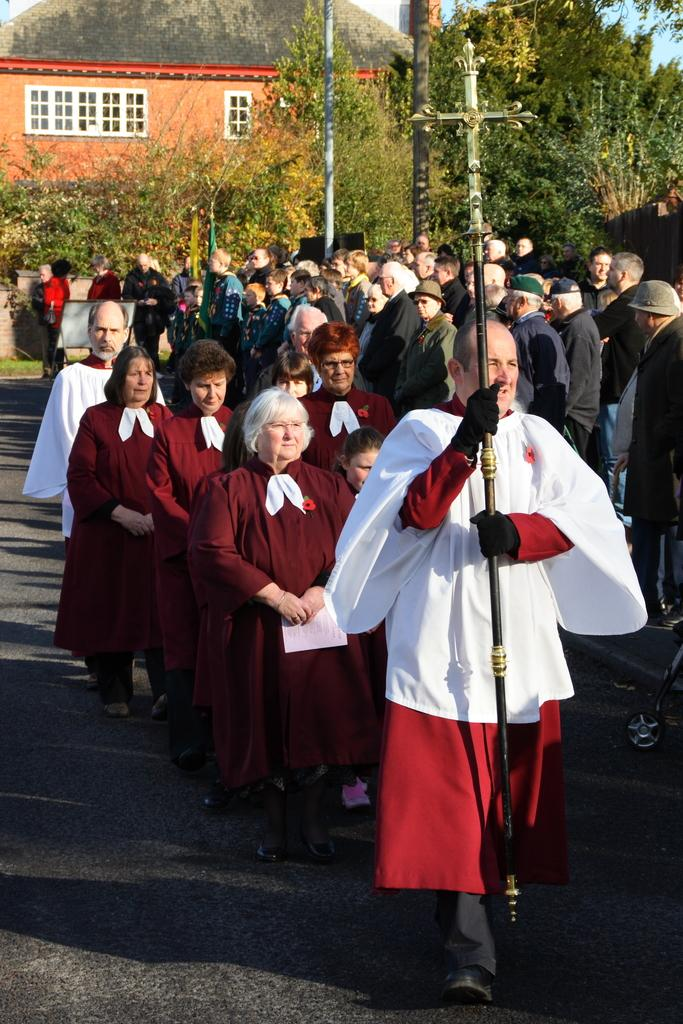What is happening on the road in the image? There are a lot of people on the road in the image. What is the priest doing in the image? The priest is carrying the Christ cross in the image. What can be seen in the background of the image? There are many trees visible in the image. Where is the goat standing in the image? There is no goat present in the image. What is the priest using to collect water in the image? There is no bucket or water collection activity depicted in the image. 